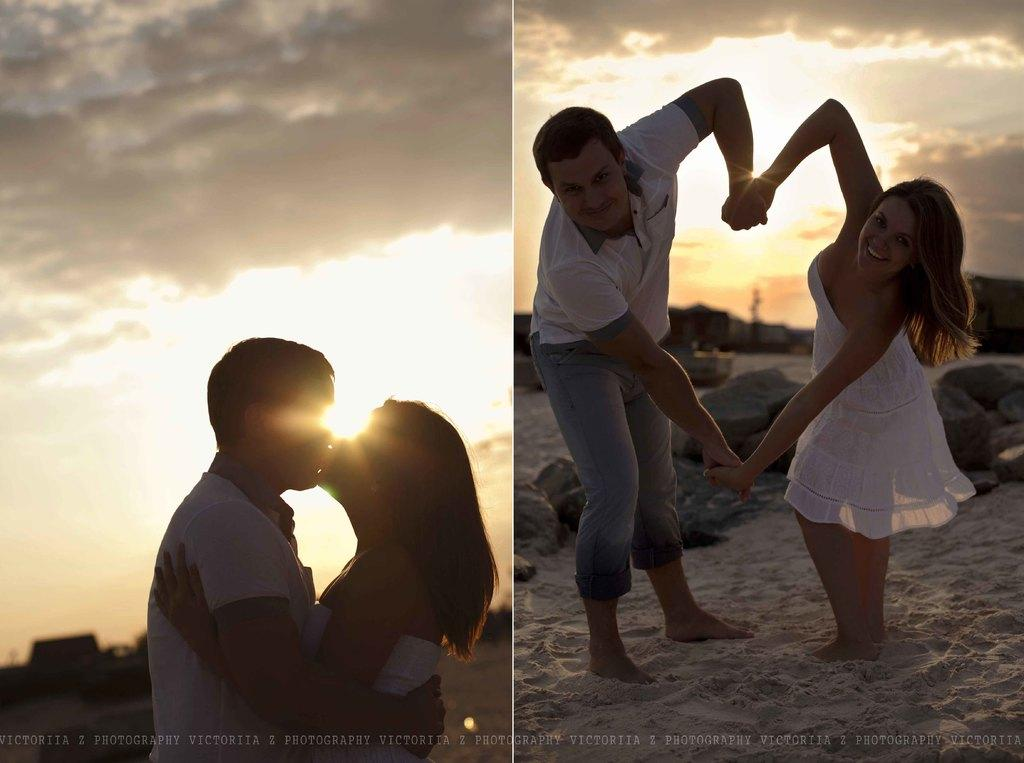What is the main subject of the image? The main subject of the image is a collage of two pictures. What is happening in the first picture? In the first picture, a lady and a guy are kissing. What is happening in the second picture? In the second picture, the lady and the guy are holding their hands. Is there a spy observing the couple in the image? There is no indication of a spy or any third party observing the couple in the image. 